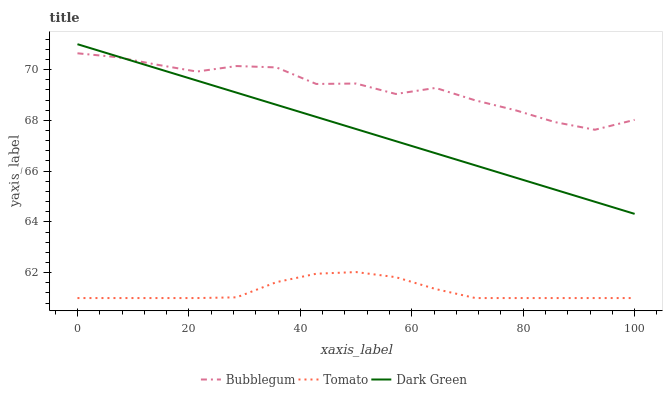Does Tomato have the minimum area under the curve?
Answer yes or no. Yes. Does Bubblegum have the maximum area under the curve?
Answer yes or no. Yes. Does Dark Green have the minimum area under the curve?
Answer yes or no. No. Does Dark Green have the maximum area under the curve?
Answer yes or no. No. Is Dark Green the smoothest?
Answer yes or no. Yes. Is Bubblegum the roughest?
Answer yes or no. Yes. Is Bubblegum the smoothest?
Answer yes or no. No. Is Dark Green the roughest?
Answer yes or no. No. Does Tomato have the lowest value?
Answer yes or no. Yes. Does Dark Green have the lowest value?
Answer yes or no. No. Does Dark Green have the highest value?
Answer yes or no. Yes. Does Bubblegum have the highest value?
Answer yes or no. No. Is Tomato less than Bubblegum?
Answer yes or no. Yes. Is Dark Green greater than Tomato?
Answer yes or no. Yes. Does Dark Green intersect Bubblegum?
Answer yes or no. Yes. Is Dark Green less than Bubblegum?
Answer yes or no. No. Is Dark Green greater than Bubblegum?
Answer yes or no. No. Does Tomato intersect Bubblegum?
Answer yes or no. No. 